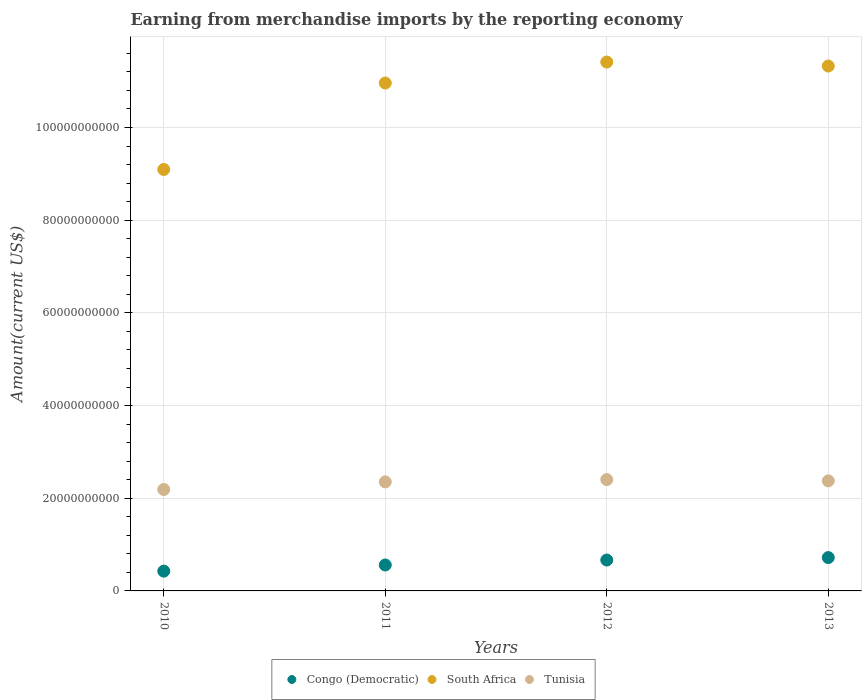What is the amount earned from merchandise imports in South Africa in 2010?
Offer a terse response. 9.09e+1. Across all years, what is the maximum amount earned from merchandise imports in Congo (Democratic)?
Ensure brevity in your answer.  7.19e+09. Across all years, what is the minimum amount earned from merchandise imports in Congo (Democratic)?
Ensure brevity in your answer.  4.27e+09. In which year was the amount earned from merchandise imports in South Africa minimum?
Provide a short and direct response. 2010. What is the total amount earned from merchandise imports in South Africa in the graph?
Offer a terse response. 4.28e+11. What is the difference between the amount earned from merchandise imports in South Africa in 2011 and that in 2013?
Provide a short and direct response. -3.66e+09. What is the difference between the amount earned from merchandise imports in Congo (Democratic) in 2013 and the amount earned from merchandise imports in South Africa in 2010?
Offer a terse response. -8.37e+1. What is the average amount earned from merchandise imports in South Africa per year?
Offer a terse response. 1.07e+11. In the year 2012, what is the difference between the amount earned from merchandise imports in Congo (Democratic) and amount earned from merchandise imports in South Africa?
Ensure brevity in your answer.  -1.07e+11. In how many years, is the amount earned from merchandise imports in South Africa greater than 100000000000 US$?
Make the answer very short. 3. What is the ratio of the amount earned from merchandise imports in South Africa in 2010 to that in 2013?
Offer a very short reply. 0.8. Is the amount earned from merchandise imports in South Africa in 2011 less than that in 2013?
Make the answer very short. Yes. What is the difference between the highest and the second highest amount earned from merchandise imports in South Africa?
Your answer should be compact. 8.65e+08. What is the difference between the highest and the lowest amount earned from merchandise imports in Congo (Democratic)?
Keep it short and to the point. 2.92e+09. Is it the case that in every year, the sum of the amount earned from merchandise imports in South Africa and amount earned from merchandise imports in Tunisia  is greater than the amount earned from merchandise imports in Congo (Democratic)?
Offer a very short reply. Yes. Does the amount earned from merchandise imports in Tunisia monotonically increase over the years?
Provide a short and direct response. No. Is the amount earned from merchandise imports in Tunisia strictly less than the amount earned from merchandise imports in Congo (Democratic) over the years?
Provide a short and direct response. No. How many years are there in the graph?
Your response must be concise. 4. What is the difference between two consecutive major ticks on the Y-axis?
Provide a short and direct response. 2.00e+1. Does the graph contain any zero values?
Your answer should be compact. No. Where does the legend appear in the graph?
Your answer should be very brief. Bottom center. How many legend labels are there?
Offer a terse response. 3. What is the title of the graph?
Make the answer very short. Earning from merchandise imports by the reporting economy. Does "Turkey" appear as one of the legend labels in the graph?
Give a very brief answer. No. What is the label or title of the X-axis?
Your answer should be compact. Years. What is the label or title of the Y-axis?
Make the answer very short. Amount(current US$). What is the Amount(current US$) of Congo (Democratic) in 2010?
Your answer should be very brief. 4.27e+09. What is the Amount(current US$) in South Africa in 2010?
Provide a short and direct response. 9.09e+1. What is the Amount(current US$) of Tunisia in 2010?
Make the answer very short. 2.19e+1. What is the Amount(current US$) of Congo (Democratic) in 2011?
Offer a terse response. 5.60e+09. What is the Amount(current US$) in South Africa in 2011?
Provide a succinct answer. 1.10e+11. What is the Amount(current US$) of Tunisia in 2011?
Give a very brief answer. 2.35e+1. What is the Amount(current US$) of Congo (Democratic) in 2012?
Your answer should be very brief. 6.66e+09. What is the Amount(current US$) of South Africa in 2012?
Your answer should be compact. 1.14e+11. What is the Amount(current US$) in Tunisia in 2012?
Give a very brief answer. 2.40e+1. What is the Amount(current US$) of Congo (Democratic) in 2013?
Provide a short and direct response. 7.19e+09. What is the Amount(current US$) of South Africa in 2013?
Your answer should be compact. 1.13e+11. What is the Amount(current US$) of Tunisia in 2013?
Your answer should be very brief. 2.37e+1. Across all years, what is the maximum Amount(current US$) of Congo (Democratic)?
Provide a short and direct response. 7.19e+09. Across all years, what is the maximum Amount(current US$) of South Africa?
Ensure brevity in your answer.  1.14e+11. Across all years, what is the maximum Amount(current US$) in Tunisia?
Give a very brief answer. 2.40e+1. Across all years, what is the minimum Amount(current US$) in Congo (Democratic)?
Ensure brevity in your answer.  4.27e+09. Across all years, what is the minimum Amount(current US$) in South Africa?
Your answer should be compact. 9.09e+1. Across all years, what is the minimum Amount(current US$) in Tunisia?
Give a very brief answer. 2.19e+1. What is the total Amount(current US$) in Congo (Democratic) in the graph?
Offer a very short reply. 2.37e+1. What is the total Amount(current US$) of South Africa in the graph?
Keep it short and to the point. 4.28e+11. What is the total Amount(current US$) in Tunisia in the graph?
Provide a succinct answer. 9.32e+1. What is the difference between the Amount(current US$) in Congo (Democratic) in 2010 and that in 2011?
Keep it short and to the point. -1.33e+09. What is the difference between the Amount(current US$) in South Africa in 2010 and that in 2011?
Ensure brevity in your answer.  -1.87e+1. What is the difference between the Amount(current US$) of Tunisia in 2010 and that in 2011?
Your answer should be compact. -1.64e+09. What is the difference between the Amount(current US$) of Congo (Democratic) in 2010 and that in 2012?
Keep it short and to the point. -2.39e+09. What is the difference between the Amount(current US$) of South Africa in 2010 and that in 2012?
Offer a very short reply. -2.32e+1. What is the difference between the Amount(current US$) in Tunisia in 2010 and that in 2012?
Keep it short and to the point. -2.13e+09. What is the difference between the Amount(current US$) in Congo (Democratic) in 2010 and that in 2013?
Provide a short and direct response. -2.92e+09. What is the difference between the Amount(current US$) in South Africa in 2010 and that in 2013?
Make the answer very short. -2.23e+1. What is the difference between the Amount(current US$) of Tunisia in 2010 and that in 2013?
Ensure brevity in your answer.  -1.85e+09. What is the difference between the Amount(current US$) of Congo (Democratic) in 2011 and that in 2012?
Provide a short and direct response. -1.07e+09. What is the difference between the Amount(current US$) in South Africa in 2011 and that in 2012?
Provide a succinct answer. -4.53e+09. What is the difference between the Amount(current US$) in Tunisia in 2011 and that in 2012?
Give a very brief answer. -4.97e+08. What is the difference between the Amount(current US$) of Congo (Democratic) in 2011 and that in 2013?
Your answer should be compact. -1.60e+09. What is the difference between the Amount(current US$) in South Africa in 2011 and that in 2013?
Keep it short and to the point. -3.66e+09. What is the difference between the Amount(current US$) in Tunisia in 2011 and that in 2013?
Your answer should be very brief. -2.18e+08. What is the difference between the Amount(current US$) of Congo (Democratic) in 2012 and that in 2013?
Your response must be concise. -5.30e+08. What is the difference between the Amount(current US$) of South Africa in 2012 and that in 2013?
Your response must be concise. 8.65e+08. What is the difference between the Amount(current US$) in Tunisia in 2012 and that in 2013?
Offer a very short reply. 2.79e+08. What is the difference between the Amount(current US$) in Congo (Democratic) in 2010 and the Amount(current US$) in South Africa in 2011?
Give a very brief answer. -1.05e+11. What is the difference between the Amount(current US$) in Congo (Democratic) in 2010 and the Amount(current US$) in Tunisia in 2011?
Give a very brief answer. -1.93e+1. What is the difference between the Amount(current US$) in South Africa in 2010 and the Amount(current US$) in Tunisia in 2011?
Keep it short and to the point. 6.74e+1. What is the difference between the Amount(current US$) in Congo (Democratic) in 2010 and the Amount(current US$) in South Africa in 2012?
Give a very brief answer. -1.10e+11. What is the difference between the Amount(current US$) in Congo (Democratic) in 2010 and the Amount(current US$) in Tunisia in 2012?
Provide a short and direct response. -1.98e+1. What is the difference between the Amount(current US$) of South Africa in 2010 and the Amount(current US$) of Tunisia in 2012?
Make the answer very short. 6.69e+1. What is the difference between the Amount(current US$) of Congo (Democratic) in 2010 and the Amount(current US$) of South Africa in 2013?
Give a very brief answer. -1.09e+11. What is the difference between the Amount(current US$) in Congo (Democratic) in 2010 and the Amount(current US$) in Tunisia in 2013?
Offer a very short reply. -1.95e+1. What is the difference between the Amount(current US$) in South Africa in 2010 and the Amount(current US$) in Tunisia in 2013?
Provide a succinct answer. 6.72e+1. What is the difference between the Amount(current US$) of Congo (Democratic) in 2011 and the Amount(current US$) of South Africa in 2012?
Your answer should be compact. -1.09e+11. What is the difference between the Amount(current US$) of Congo (Democratic) in 2011 and the Amount(current US$) of Tunisia in 2012?
Your answer should be compact. -1.84e+1. What is the difference between the Amount(current US$) in South Africa in 2011 and the Amount(current US$) in Tunisia in 2012?
Give a very brief answer. 8.56e+1. What is the difference between the Amount(current US$) in Congo (Democratic) in 2011 and the Amount(current US$) in South Africa in 2013?
Offer a terse response. -1.08e+11. What is the difference between the Amount(current US$) of Congo (Democratic) in 2011 and the Amount(current US$) of Tunisia in 2013?
Keep it short and to the point. -1.81e+1. What is the difference between the Amount(current US$) in South Africa in 2011 and the Amount(current US$) in Tunisia in 2013?
Your answer should be very brief. 8.58e+1. What is the difference between the Amount(current US$) of Congo (Democratic) in 2012 and the Amount(current US$) of South Africa in 2013?
Your answer should be very brief. -1.07e+11. What is the difference between the Amount(current US$) of Congo (Democratic) in 2012 and the Amount(current US$) of Tunisia in 2013?
Your response must be concise. -1.71e+1. What is the difference between the Amount(current US$) in South Africa in 2012 and the Amount(current US$) in Tunisia in 2013?
Give a very brief answer. 9.04e+1. What is the average Amount(current US$) in Congo (Democratic) per year?
Make the answer very short. 5.93e+09. What is the average Amount(current US$) in South Africa per year?
Keep it short and to the point. 1.07e+11. What is the average Amount(current US$) in Tunisia per year?
Your answer should be compact. 2.33e+1. In the year 2010, what is the difference between the Amount(current US$) of Congo (Democratic) and Amount(current US$) of South Africa?
Make the answer very short. -8.67e+1. In the year 2010, what is the difference between the Amount(current US$) in Congo (Democratic) and Amount(current US$) in Tunisia?
Make the answer very short. -1.76e+1. In the year 2010, what is the difference between the Amount(current US$) of South Africa and Amount(current US$) of Tunisia?
Provide a short and direct response. 6.90e+1. In the year 2011, what is the difference between the Amount(current US$) of Congo (Democratic) and Amount(current US$) of South Africa?
Ensure brevity in your answer.  -1.04e+11. In the year 2011, what is the difference between the Amount(current US$) in Congo (Democratic) and Amount(current US$) in Tunisia?
Provide a short and direct response. -1.79e+1. In the year 2011, what is the difference between the Amount(current US$) of South Africa and Amount(current US$) of Tunisia?
Your answer should be very brief. 8.61e+1. In the year 2012, what is the difference between the Amount(current US$) of Congo (Democratic) and Amount(current US$) of South Africa?
Offer a very short reply. -1.07e+11. In the year 2012, what is the difference between the Amount(current US$) of Congo (Democratic) and Amount(current US$) of Tunisia?
Ensure brevity in your answer.  -1.74e+1. In the year 2012, what is the difference between the Amount(current US$) in South Africa and Amount(current US$) in Tunisia?
Your answer should be compact. 9.01e+1. In the year 2013, what is the difference between the Amount(current US$) in Congo (Democratic) and Amount(current US$) in South Africa?
Make the answer very short. -1.06e+11. In the year 2013, what is the difference between the Amount(current US$) in Congo (Democratic) and Amount(current US$) in Tunisia?
Offer a terse response. -1.65e+1. In the year 2013, what is the difference between the Amount(current US$) of South Africa and Amount(current US$) of Tunisia?
Provide a succinct answer. 8.95e+1. What is the ratio of the Amount(current US$) of Congo (Democratic) in 2010 to that in 2011?
Offer a terse response. 0.76. What is the ratio of the Amount(current US$) in South Africa in 2010 to that in 2011?
Your response must be concise. 0.83. What is the ratio of the Amount(current US$) in Tunisia in 2010 to that in 2011?
Provide a succinct answer. 0.93. What is the ratio of the Amount(current US$) in Congo (Democratic) in 2010 to that in 2012?
Your answer should be compact. 0.64. What is the ratio of the Amount(current US$) of South Africa in 2010 to that in 2012?
Provide a succinct answer. 0.8. What is the ratio of the Amount(current US$) of Tunisia in 2010 to that in 2012?
Your response must be concise. 0.91. What is the ratio of the Amount(current US$) in Congo (Democratic) in 2010 to that in 2013?
Offer a terse response. 0.59. What is the ratio of the Amount(current US$) of South Africa in 2010 to that in 2013?
Keep it short and to the point. 0.8. What is the ratio of the Amount(current US$) of Tunisia in 2010 to that in 2013?
Offer a terse response. 0.92. What is the ratio of the Amount(current US$) in Congo (Democratic) in 2011 to that in 2012?
Provide a short and direct response. 0.84. What is the ratio of the Amount(current US$) in South Africa in 2011 to that in 2012?
Provide a succinct answer. 0.96. What is the ratio of the Amount(current US$) in Tunisia in 2011 to that in 2012?
Give a very brief answer. 0.98. What is the ratio of the Amount(current US$) in Congo (Democratic) in 2011 to that in 2013?
Your answer should be compact. 0.78. What is the ratio of the Amount(current US$) of South Africa in 2011 to that in 2013?
Keep it short and to the point. 0.97. What is the ratio of the Amount(current US$) in Congo (Democratic) in 2012 to that in 2013?
Your answer should be very brief. 0.93. What is the ratio of the Amount(current US$) in South Africa in 2012 to that in 2013?
Your answer should be very brief. 1.01. What is the ratio of the Amount(current US$) of Tunisia in 2012 to that in 2013?
Provide a short and direct response. 1.01. What is the difference between the highest and the second highest Amount(current US$) of Congo (Democratic)?
Offer a very short reply. 5.30e+08. What is the difference between the highest and the second highest Amount(current US$) in South Africa?
Your response must be concise. 8.65e+08. What is the difference between the highest and the second highest Amount(current US$) of Tunisia?
Provide a short and direct response. 2.79e+08. What is the difference between the highest and the lowest Amount(current US$) of Congo (Democratic)?
Your answer should be compact. 2.92e+09. What is the difference between the highest and the lowest Amount(current US$) in South Africa?
Give a very brief answer. 2.32e+1. What is the difference between the highest and the lowest Amount(current US$) in Tunisia?
Your response must be concise. 2.13e+09. 